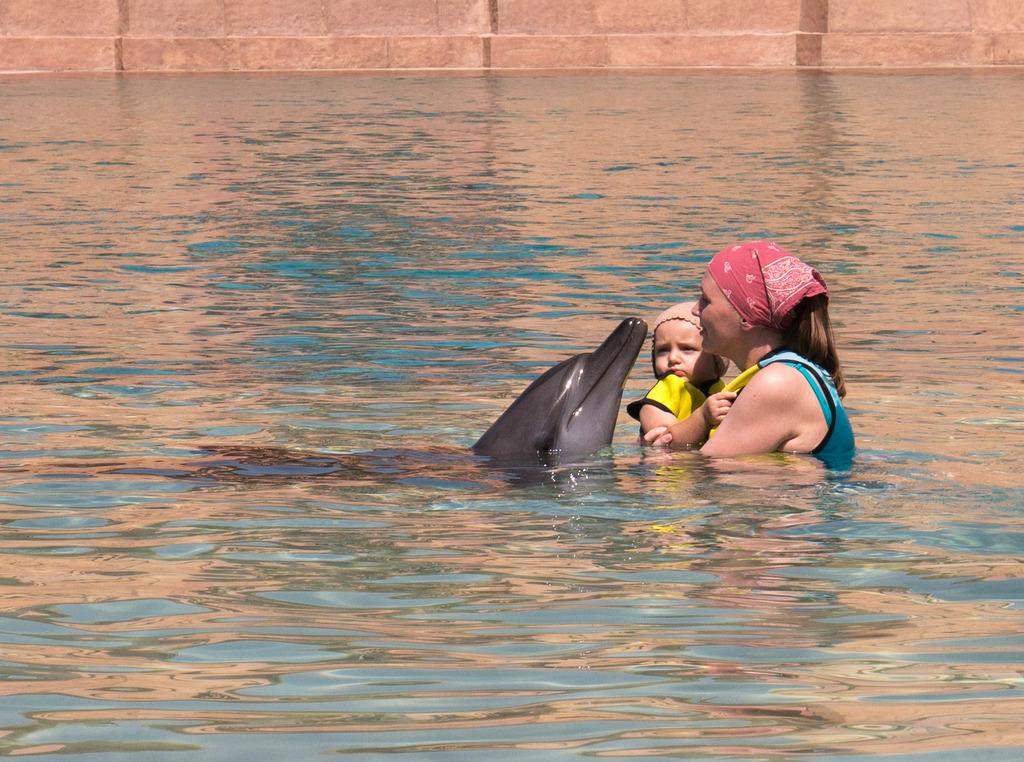What animal can be seen in the water in the image? There is a dolphin in the water in the image. What is the woman in the image doing? The woman is holding a baby in the image. How is the woman's head covered in the image? The woman is wearing a cloth on her head. What is the baby wearing on its head in the image? The baby is wearing a cap. What type of structure is visible in the image? There is a wall visible in the image. How many thumbs can be seen on the woman's hands in the image? There is no visible thumb on the woman's hands in the image. What type of bird is sitting next to the woman in the image? There is no bird present in the image; it features a woman holding a baby, a dolphin in the water, and a wall. 